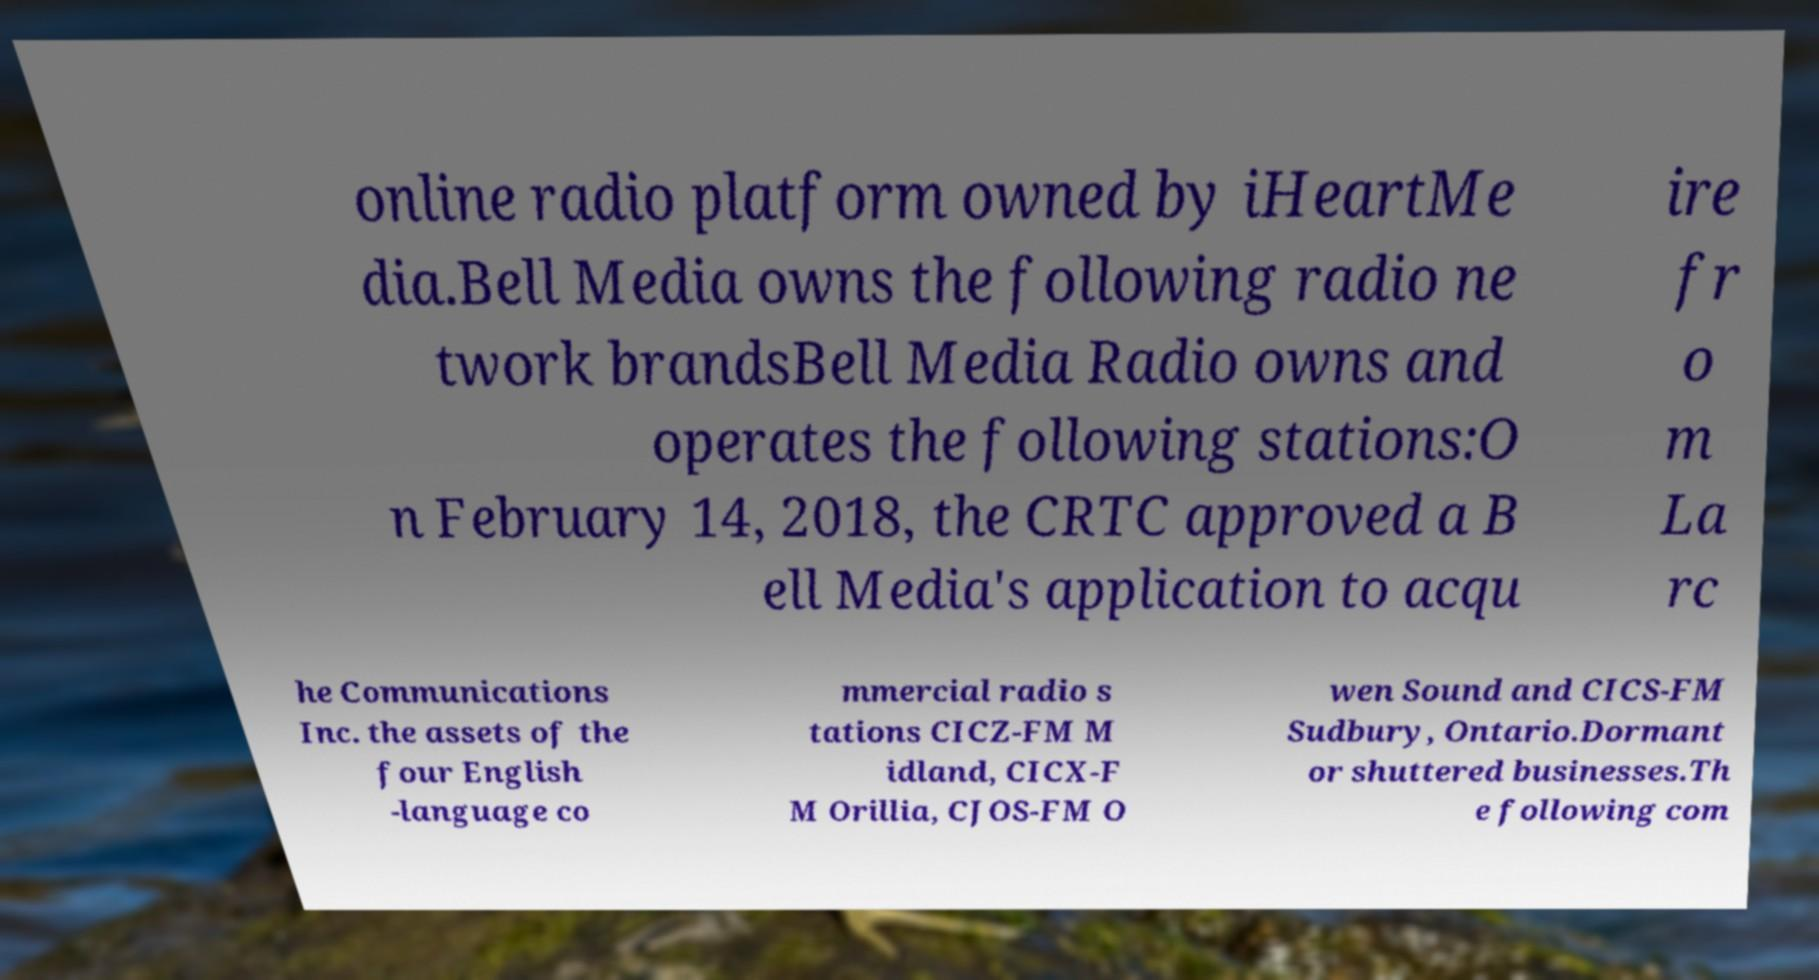There's text embedded in this image that I need extracted. Can you transcribe it verbatim? online radio platform owned by iHeartMe dia.Bell Media owns the following radio ne twork brandsBell Media Radio owns and operates the following stations:O n February 14, 2018, the CRTC approved a B ell Media's application to acqu ire fr o m La rc he Communications Inc. the assets of the four English -language co mmercial radio s tations CICZ-FM M idland, CICX-F M Orillia, CJOS-FM O wen Sound and CICS-FM Sudbury, Ontario.Dormant or shuttered businesses.Th e following com 